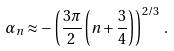Convert formula to latex. <formula><loc_0><loc_0><loc_500><loc_500>\alpha _ { n } \approx - \left ( \frac { 3 \pi } { 2 } \left ( n + \frac { 3 } { 4 } \right ) \right ) ^ { 2 / 3 } \, .</formula> 